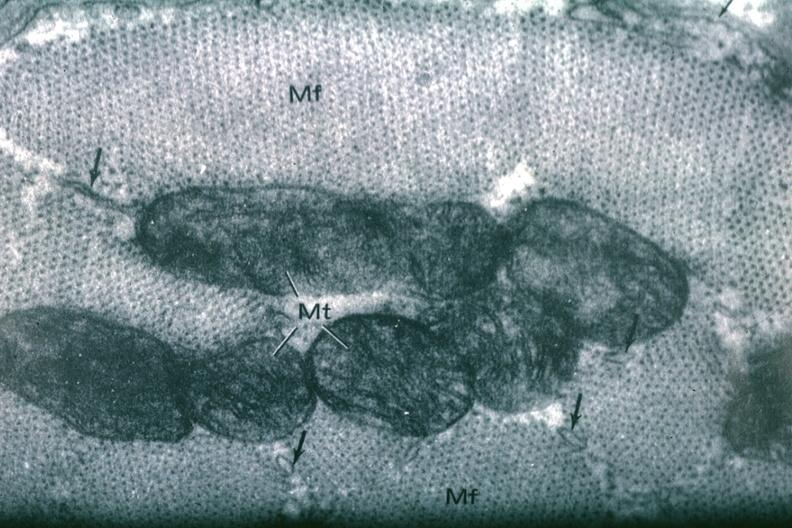what does this image show?
Answer the question using a single word or phrase. Cross section myofibril 